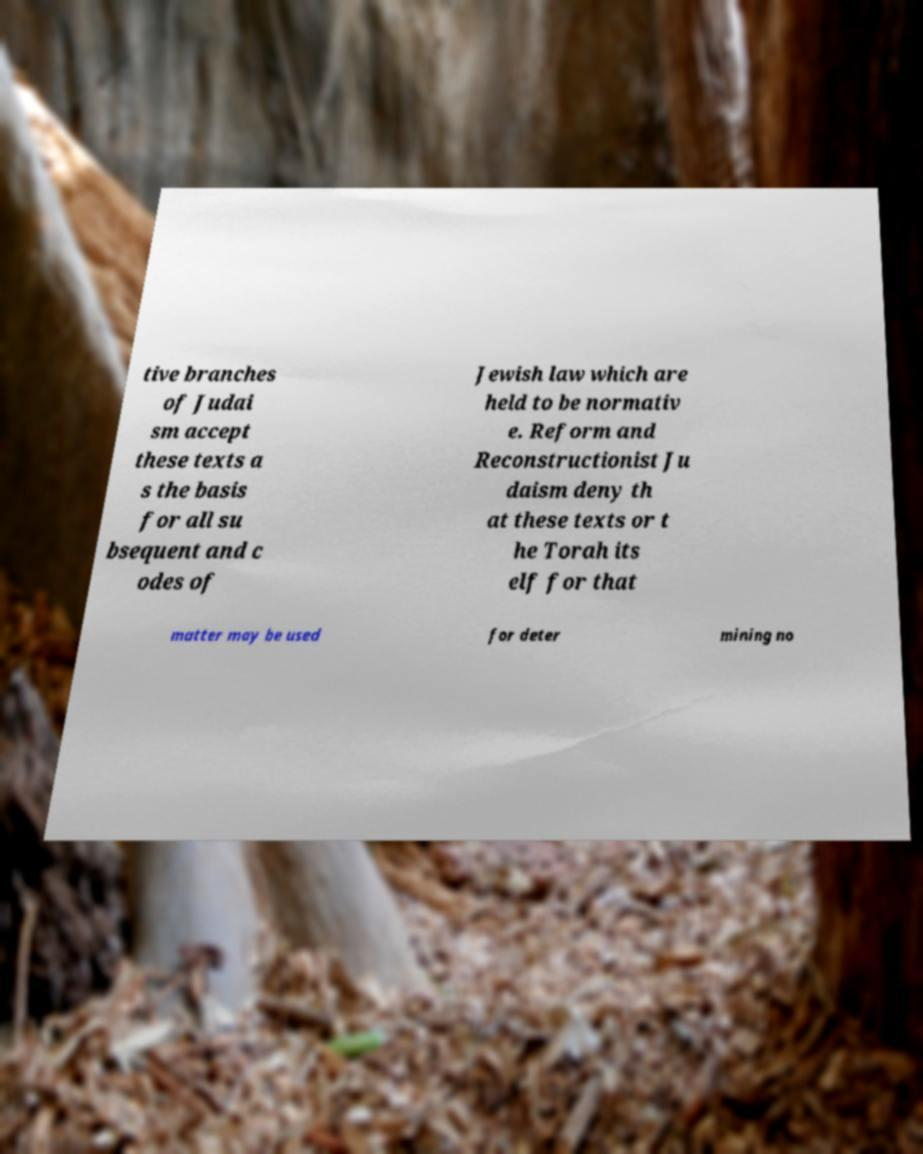I need the written content from this picture converted into text. Can you do that? tive branches of Judai sm accept these texts a s the basis for all su bsequent and c odes of Jewish law which are held to be normativ e. Reform and Reconstructionist Ju daism deny th at these texts or t he Torah its elf for that matter may be used for deter mining no 